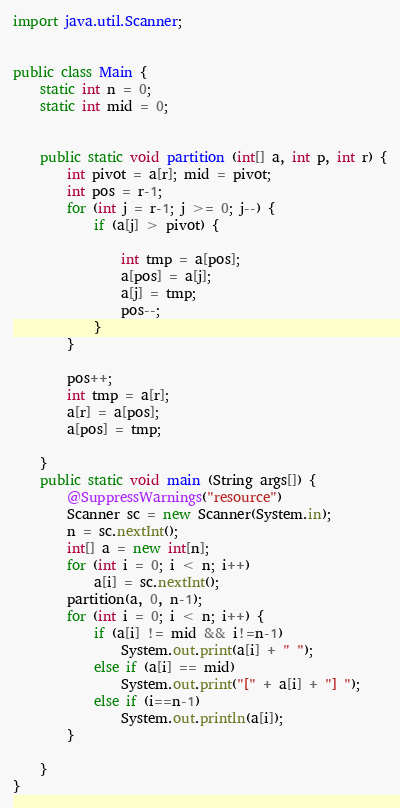Convert code to text. <code><loc_0><loc_0><loc_500><loc_500><_Java_>import java.util.Scanner;


public class Main {
	static int n = 0;
	static int mid = 0;
	

	public static void partition (int[] a, int p, int r) {
		int pivot = a[r]; mid = pivot;
		int pos = r-1;
		for (int j = r-1; j >= 0; j--) {
			if (a[j] > pivot) {
				
				int tmp = a[pos];
				a[pos] = a[j];
				a[j] = tmp;
				pos--;
			}
		}
		
		pos++;
		int tmp = a[r];
		a[r] = a[pos];
		a[pos] = tmp;
		
	}
	public static void main (String args[]) {
		@SuppressWarnings("resource")
		Scanner sc = new Scanner(System.in);
		n = sc.nextInt();
		int[] a = new int[n];
		for (int i = 0; i < n; i++) 
			a[i] = sc.nextInt();
		partition(a, 0, n-1);
		for (int i = 0; i < n; i++) {
			if (a[i] != mid && i!=n-1)
				System.out.print(a[i] + " ");
			else if (a[i] == mid)
				System.out.print("[" + a[i] + "] ");
			else if (i==n-1)
				System.out.println(a[i]);
		}
		
	}
}</code> 